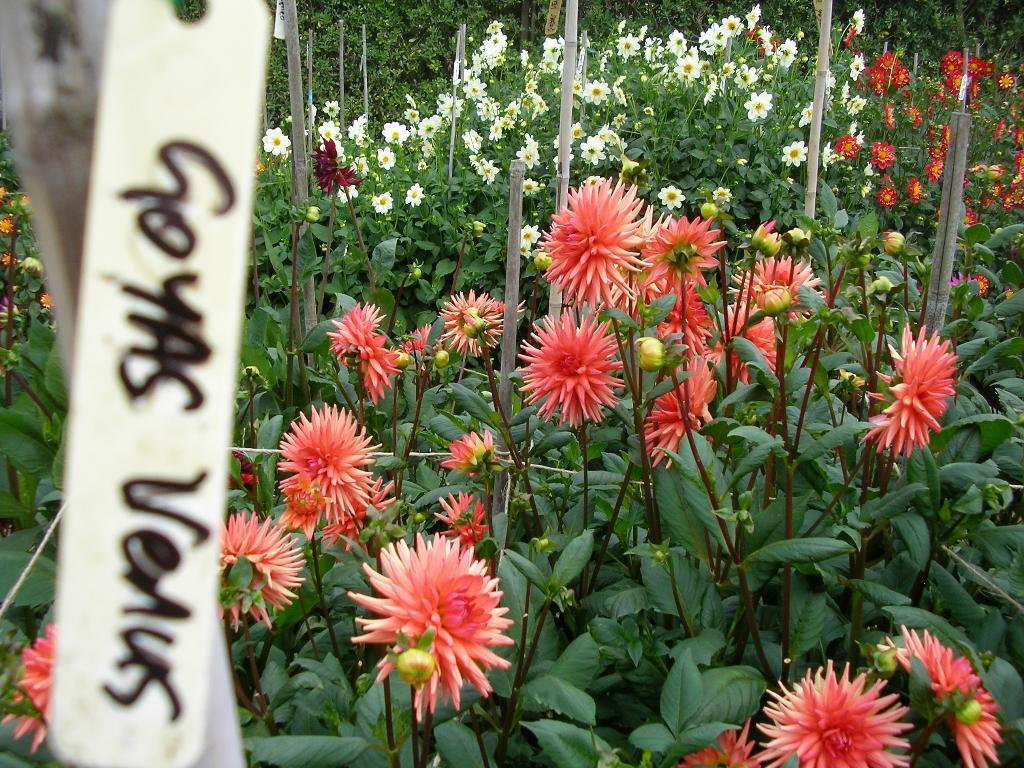What objects are in the foreground of the image? There are tags in the foreground of the image. What can be read on the tags? Text is present on the tags. What type of natural elements can be seen in the background of the image? There are flowers, plants, and sticks visible in the background of the image. What type of spot can be seen on the ground in the image? There is no mention of a spot or ground in the image; it only features tags in the foreground and natural elements in the background. 